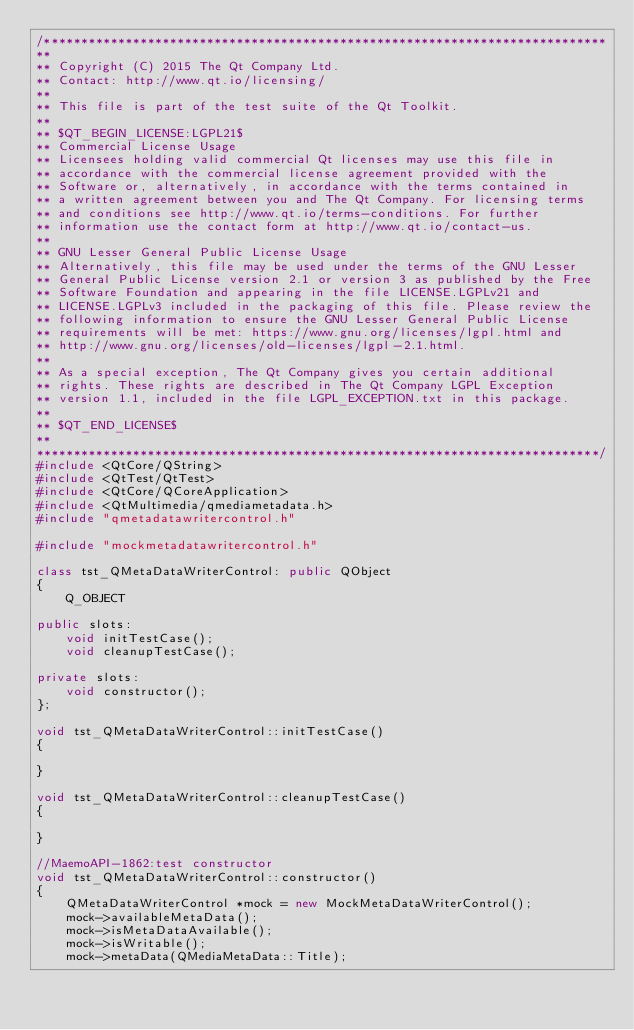<code> <loc_0><loc_0><loc_500><loc_500><_C++_>/****************************************************************************
**
** Copyright (C) 2015 The Qt Company Ltd.
** Contact: http://www.qt.io/licensing/
**
** This file is part of the test suite of the Qt Toolkit.
**
** $QT_BEGIN_LICENSE:LGPL21$
** Commercial License Usage
** Licensees holding valid commercial Qt licenses may use this file in
** accordance with the commercial license agreement provided with the
** Software or, alternatively, in accordance with the terms contained in
** a written agreement between you and The Qt Company. For licensing terms
** and conditions see http://www.qt.io/terms-conditions. For further
** information use the contact form at http://www.qt.io/contact-us.
**
** GNU Lesser General Public License Usage
** Alternatively, this file may be used under the terms of the GNU Lesser
** General Public License version 2.1 or version 3 as published by the Free
** Software Foundation and appearing in the file LICENSE.LGPLv21 and
** LICENSE.LGPLv3 included in the packaging of this file. Please review the
** following information to ensure the GNU Lesser General Public License
** requirements will be met: https://www.gnu.org/licenses/lgpl.html and
** http://www.gnu.org/licenses/old-licenses/lgpl-2.1.html.
**
** As a special exception, The Qt Company gives you certain additional
** rights. These rights are described in The Qt Company LGPL Exception
** version 1.1, included in the file LGPL_EXCEPTION.txt in this package.
**
** $QT_END_LICENSE$
**
****************************************************************************/
#include <QtCore/QString>
#include <QtTest/QtTest>
#include <QtCore/QCoreApplication>
#include <QtMultimedia/qmediametadata.h>
#include "qmetadatawritercontrol.h"

#include "mockmetadatawritercontrol.h"

class tst_QMetaDataWriterControl: public QObject
{
    Q_OBJECT

public slots:
    void initTestCase();
    void cleanupTestCase();

private slots:
    void constructor();
};

void tst_QMetaDataWriterControl::initTestCase()
{

}

void tst_QMetaDataWriterControl::cleanupTestCase()
{

}

//MaemoAPI-1862:test constructor
void tst_QMetaDataWriterControl::constructor()
{
    QMetaDataWriterControl *mock = new MockMetaDataWriterControl();
    mock->availableMetaData();
    mock->isMetaDataAvailable();
    mock->isWritable();
    mock->metaData(QMediaMetaData::Title);</code> 